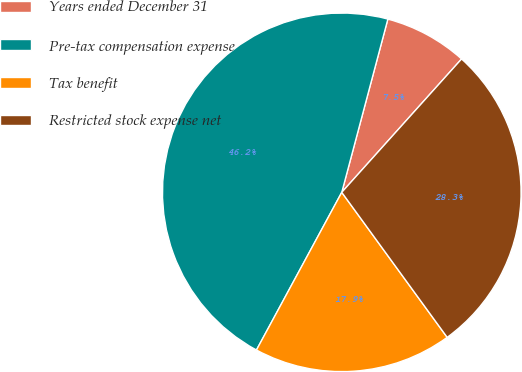<chart> <loc_0><loc_0><loc_500><loc_500><pie_chart><fcel>Years ended December 31<fcel>Pre-tax compensation expense<fcel>Tax benefit<fcel>Restricted stock expense net<nl><fcel>7.51%<fcel>46.25%<fcel>17.9%<fcel>28.35%<nl></chart> 